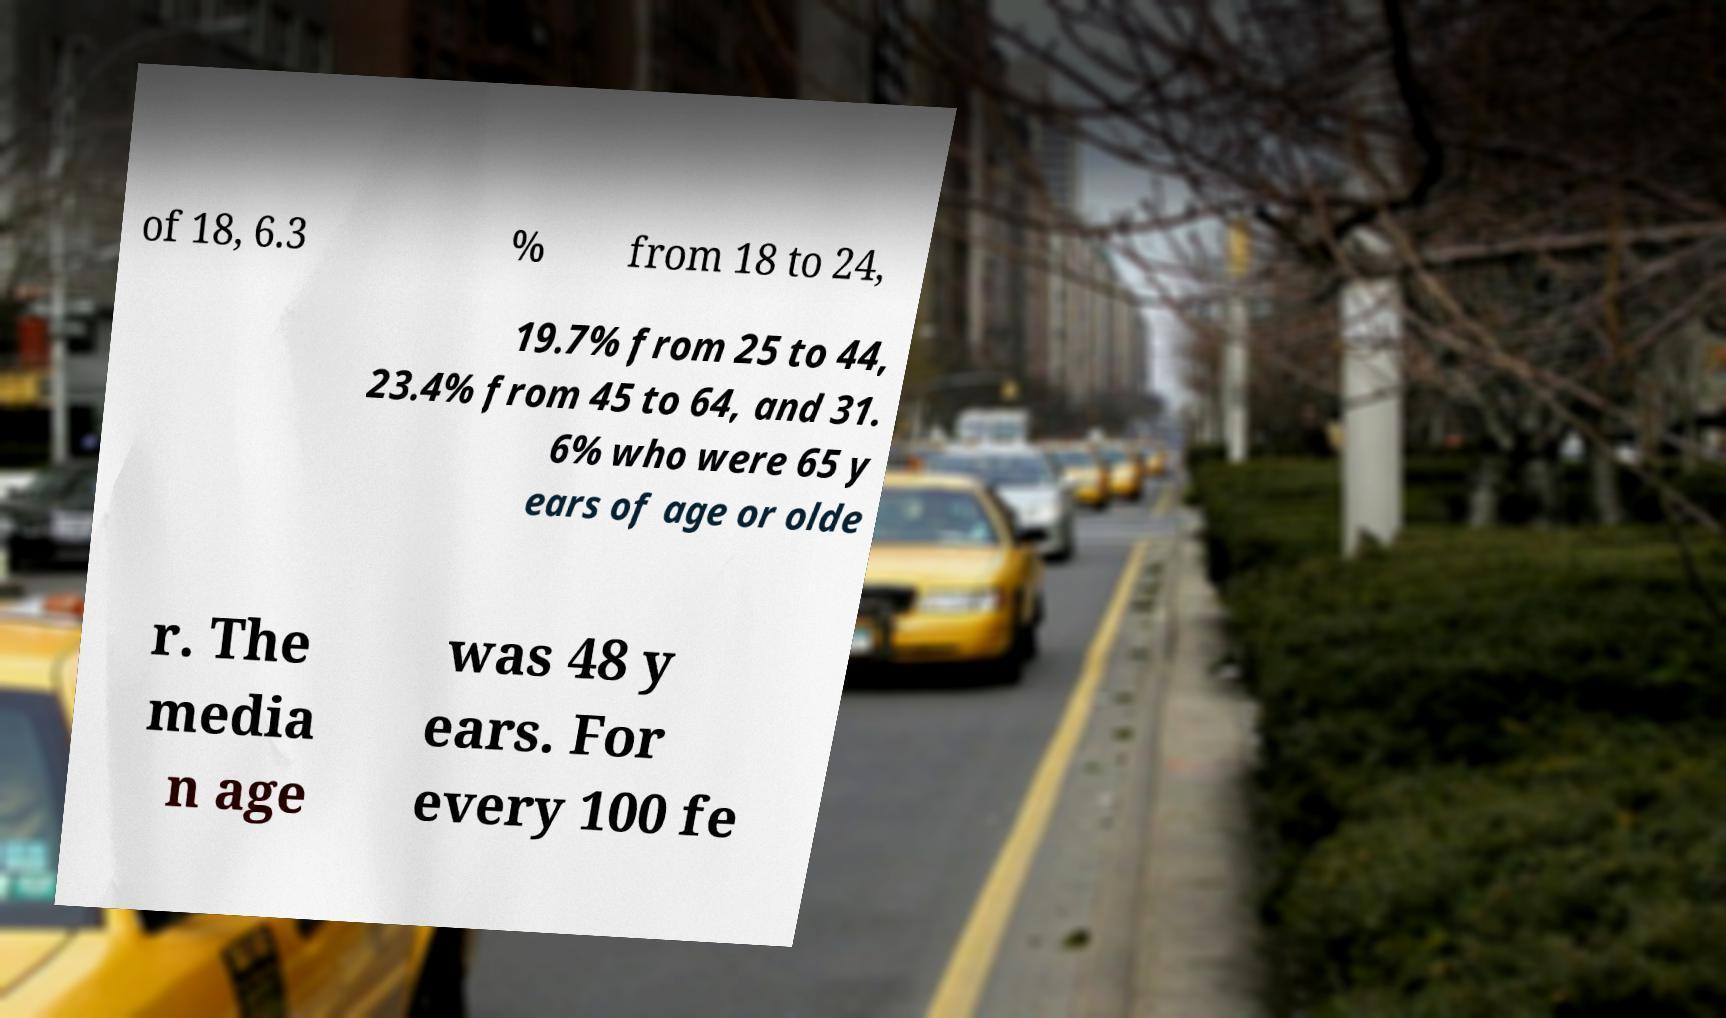Please identify and transcribe the text found in this image. of 18, 6.3 % from 18 to 24, 19.7% from 25 to 44, 23.4% from 45 to 64, and 31. 6% who were 65 y ears of age or olde r. The media n age was 48 y ears. For every 100 fe 